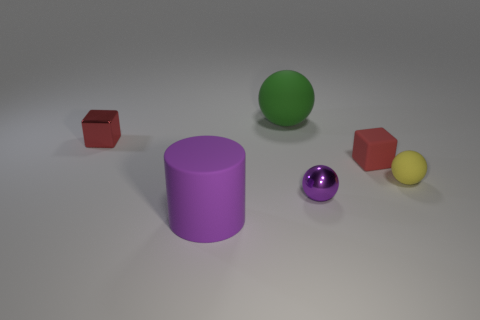Subtract all green balls. How many balls are left? 2 Subtract all green spheres. How many spheres are left? 2 Subtract all cylinders. How many objects are left? 5 Add 3 large balls. How many objects exist? 9 Subtract 2 balls. How many balls are left? 1 Subtract all brown blocks. Subtract all green cylinders. How many blocks are left? 2 Subtract all small yellow rubber balls. Subtract all small red things. How many objects are left? 3 Add 1 rubber blocks. How many rubber blocks are left? 2 Add 6 metallic cubes. How many metallic cubes exist? 7 Subtract 1 yellow balls. How many objects are left? 5 